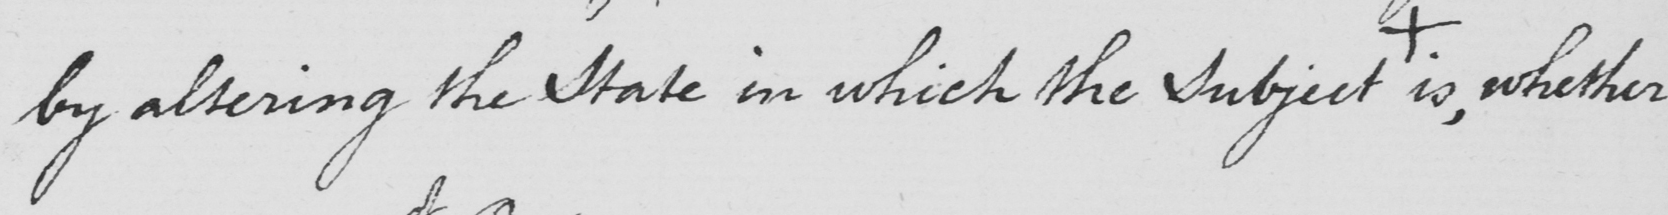Can you tell me what this handwritten text says? by altering the State in which the Subject  +  is , whether 